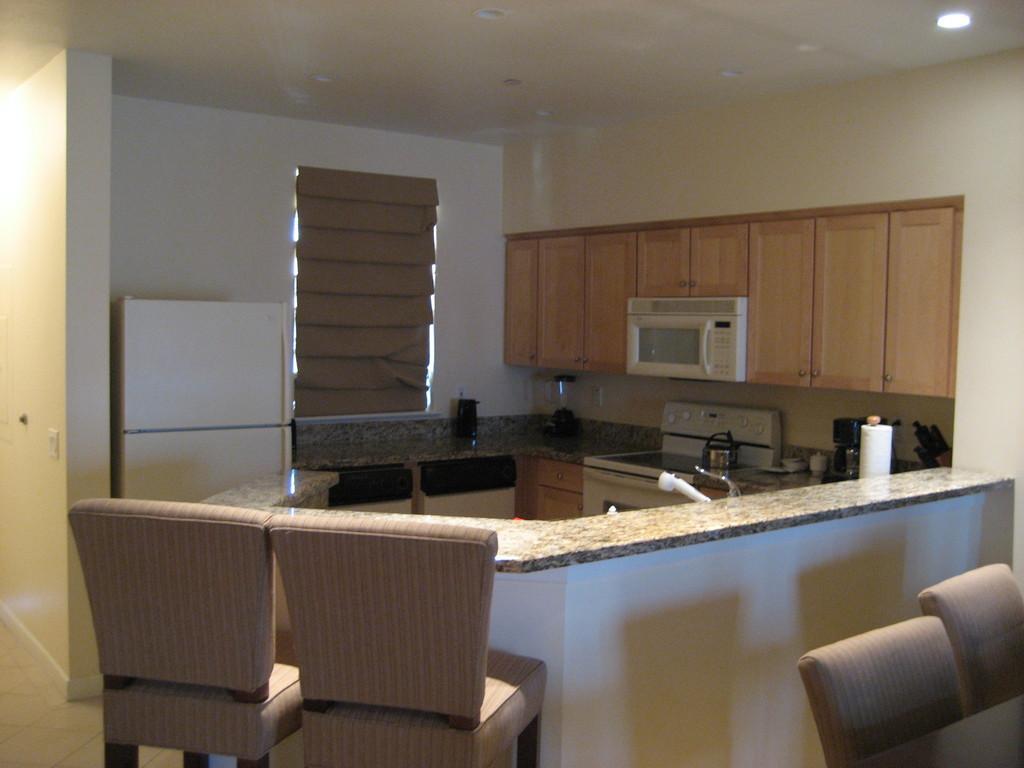Please provide a concise description of this image. In this picture we can see chairs, here we can see a wall, cupboards and some objects and in the background we can see a roof. 